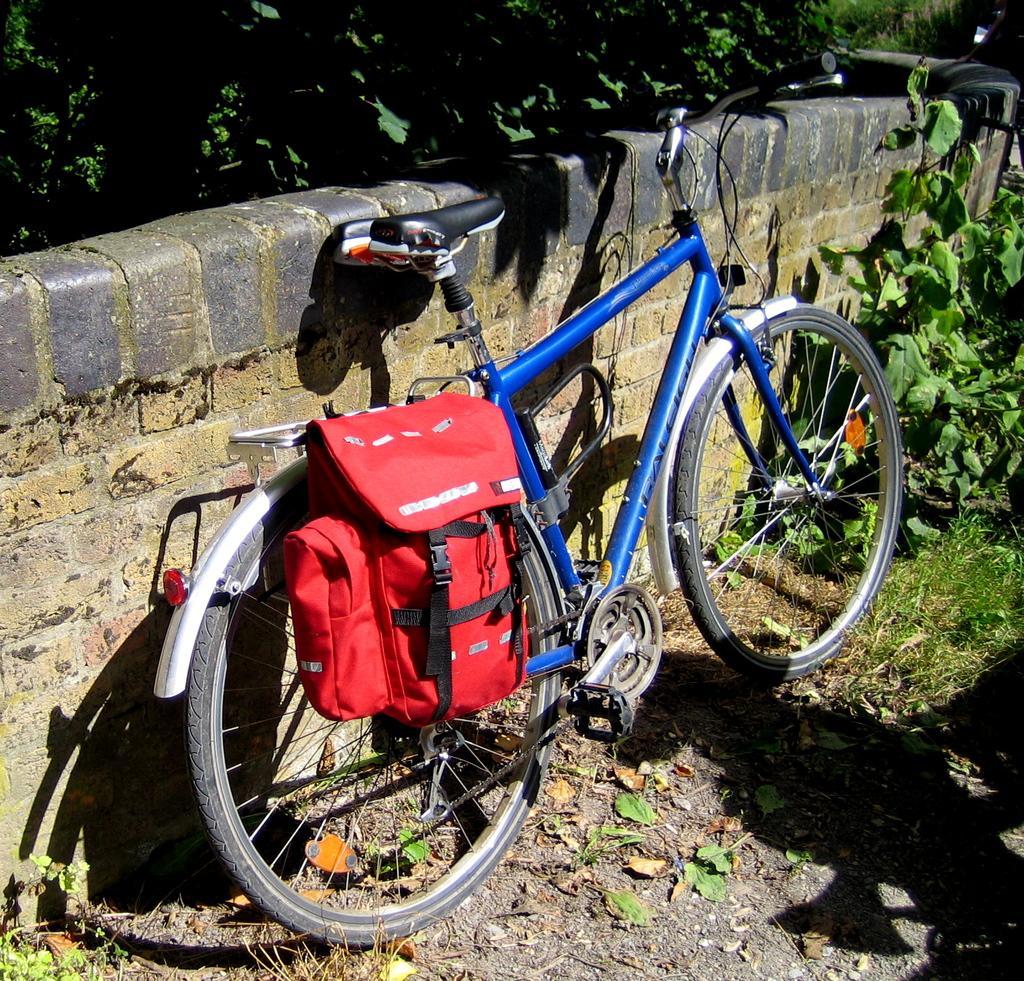Please provide a concise description of this image. In this image, we can see a bag hanging to a bicycle and in the background, we can see a wall, trees. At the bottom,there is ground. 